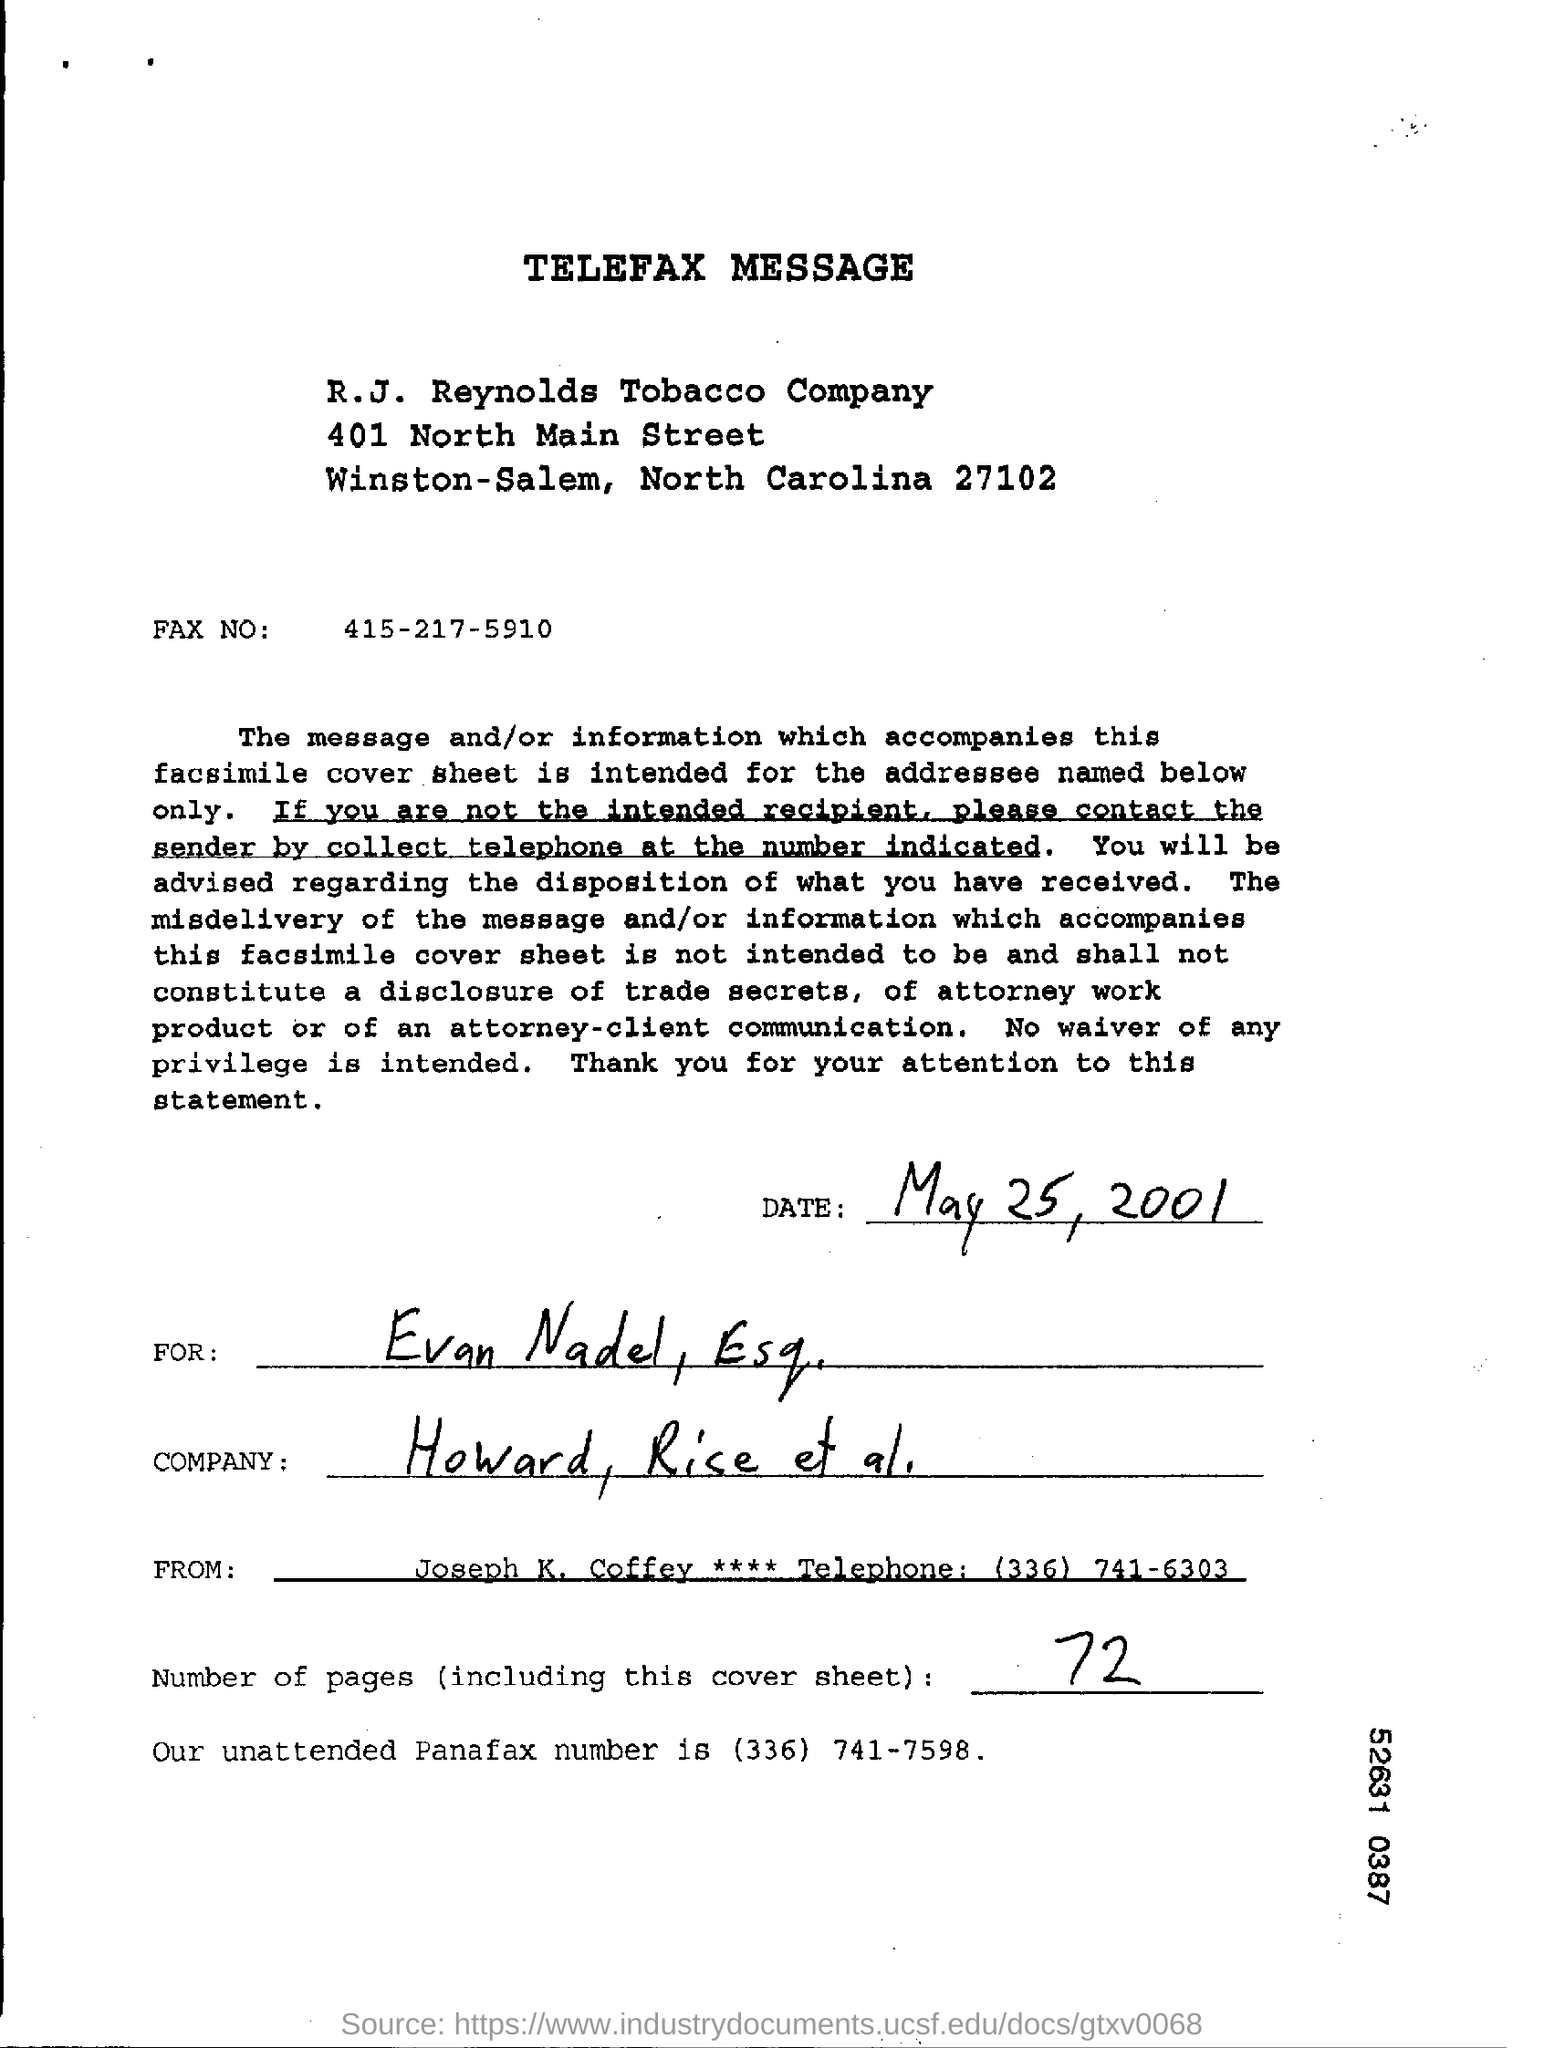Indicate a few pertinent items in this graphic. The sender of the telefax message is Joseph K. Coffey. There are a total of 72 pages, including this cover sheet. The unattended panafax number mentioned is (336) 741-7598. This document is a telefax message. The receiver of the telefax message is Evan Nadel, Esq. 